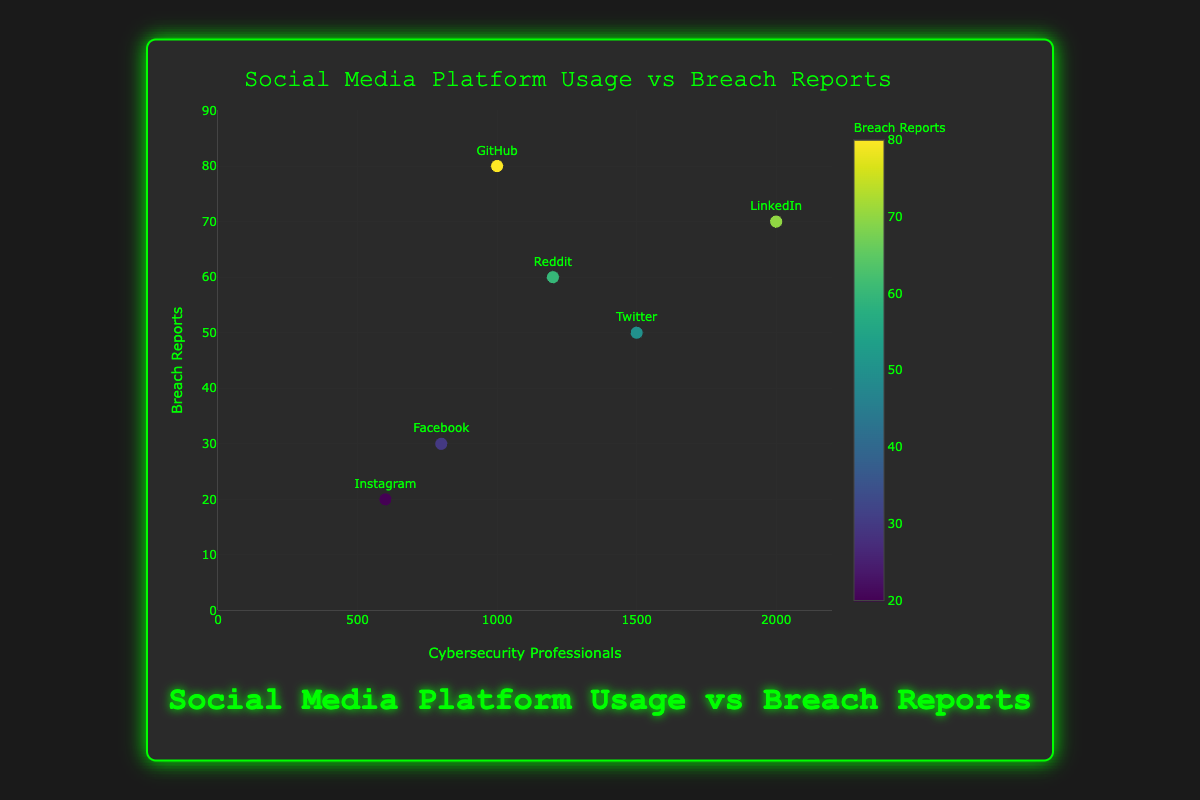what is the title of the figure? The title is displayed at the top of the chart. It reads "Social Media Platform Usage vs Breach Reports."
Answer: Social Media Platform Usage vs Breach Reports How many data points are there in the figure? Each social media platform represents a data point. Six platforms are displayed: Twitter, LinkedIn, Facebook, Reddit, Instagram, and GitHub.
Answer: 6 Which social media platform has the highest number of cybersecurity professionals? Looking at the x-axis values, LinkedIn has the highest number of cybersecurity professionals with 2000.
Answer: LinkedIn What is the range of breach reports shown on the y-axis? The y-axis ranges from 0 to 90 as indicated in the chart.
Answer: 0 to 90 Which two platforms have the closest number of cybersecurity professionals? Closely examining the x-axis values, Twitter (1500) and Reddit (1200) are the closest in number.
Answer: Twitter and Reddit What is the difference in breach reports between the platform with the highest and lowest breach reports? Github has the highest breach reports (80), and Instagram has the lowest (20). The difference is 80 - 20 = 60.
Answer: 60 Which platform shows an outlier in terms of breach reports compared to the others? GitHub stands out with 80 breach reports, significantly higher than the rest.
Answer: GitHub Which platform has the least number of cybersecurity professionals, and how many breach reports are associated with it? Instagram has the least number of cybersecurity professionals (600) and is associated with 20 breach reports.
Answer: Instagram, 20 If you sum the number of cybersecurity professionals of Facebook and Reddit, what would be the total? Facebook has 800 and Reddit has 1200 cybersecurity professionals. Their total is 800 + 1200 = 2000.
Answer: 2000 Is there a clear correlation between the number of cybersecurity professionals and breach reports across platforms? The figure does not clearly indicate a strong linear relationship since platforms with similar numbers of professionals have differing breach reports. For example, LinkedIn (2000 professionals, 70 reports) and Facebook (800 professionals, 30 reports) don’t follow a linear pattern.
Answer: No 